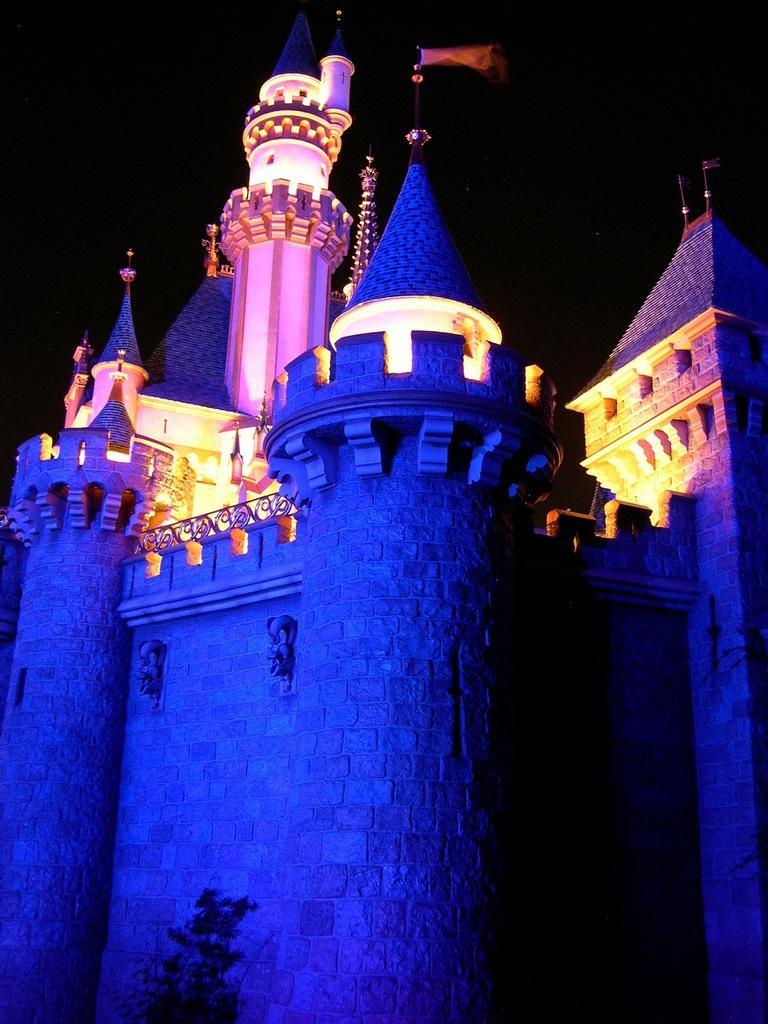Please provide a concise description of this image. In the center of the image we can see flag on the castle. In the background there is sky. 